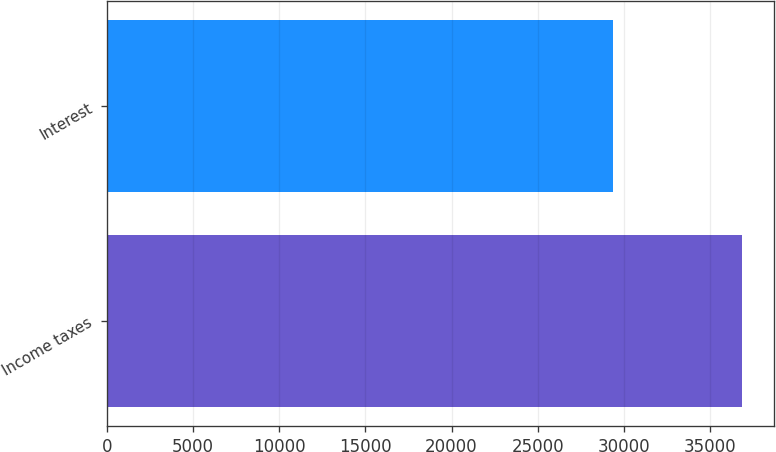<chart> <loc_0><loc_0><loc_500><loc_500><bar_chart><fcel>Income taxes<fcel>Interest<nl><fcel>36863<fcel>29354<nl></chart> 